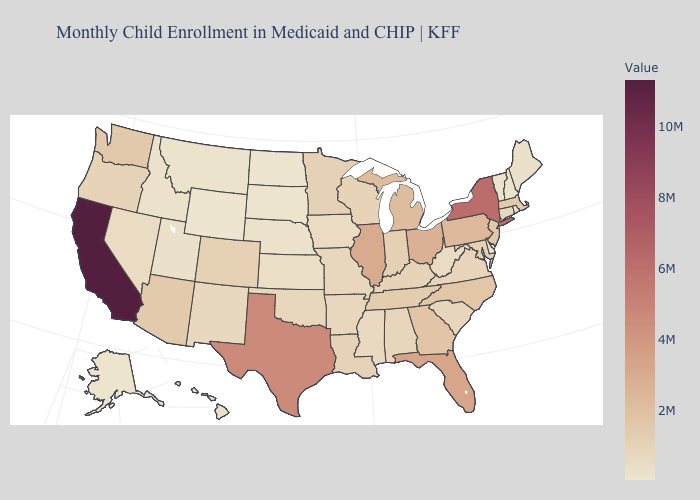Among the states that border Michigan , does Ohio have the highest value?
Give a very brief answer. Yes. Among the states that border Tennessee , does Mississippi have the lowest value?
Be succinct. Yes. Among the states that border Arkansas , does Texas have the highest value?
Concise answer only. Yes. Which states hav the highest value in the South?
Give a very brief answer. Texas. Does Arizona have a lower value than California?
Answer briefly. Yes. Among the states that border Georgia , which have the highest value?
Quick response, please. Florida. Does Maine have a lower value than New York?
Write a very short answer. Yes. 